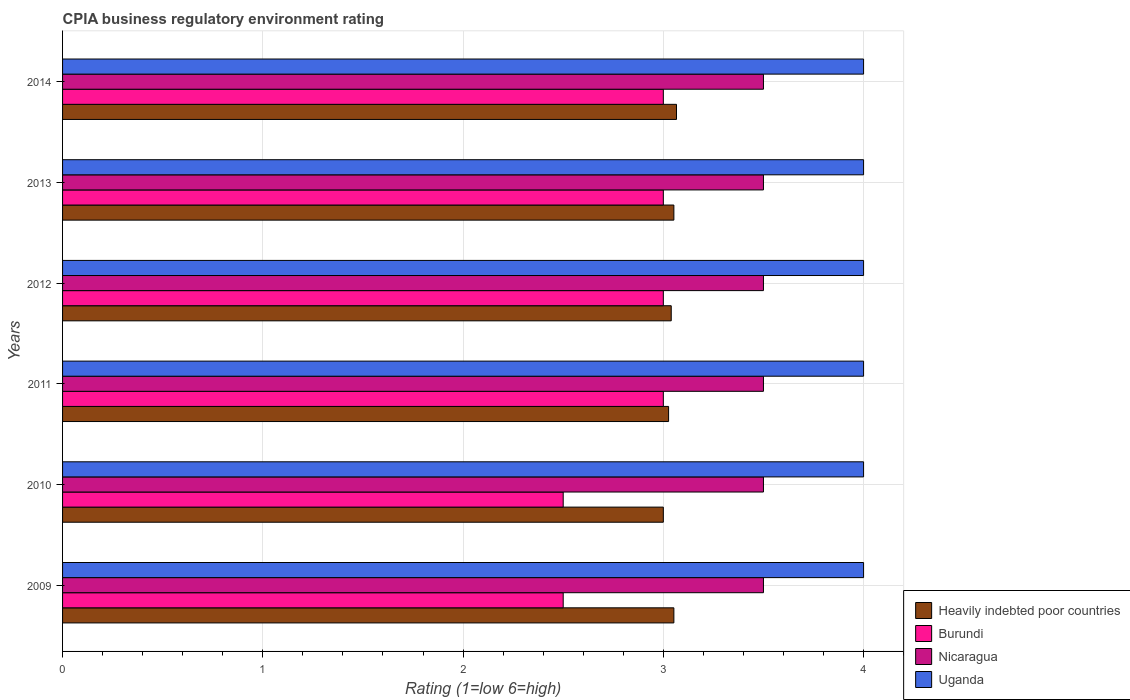How many groups of bars are there?
Offer a terse response. 6. Are the number of bars on each tick of the Y-axis equal?
Your answer should be compact. Yes. How many bars are there on the 4th tick from the top?
Your response must be concise. 4. How many bars are there on the 1st tick from the bottom?
Your answer should be very brief. 4. What is the label of the 2nd group of bars from the top?
Your response must be concise. 2013. In how many cases, is the number of bars for a given year not equal to the number of legend labels?
Keep it short and to the point. 0. Across all years, what is the minimum CPIA rating in Uganda?
Your response must be concise. 4. In which year was the CPIA rating in Heavily indebted poor countries maximum?
Your answer should be compact. 2014. In which year was the CPIA rating in Heavily indebted poor countries minimum?
Ensure brevity in your answer.  2010. What is the total CPIA rating in Heavily indebted poor countries in the graph?
Offer a very short reply. 18.24. What is the difference between the CPIA rating in Heavily indebted poor countries in 2011 and the CPIA rating in Burundi in 2014?
Make the answer very short. 0.03. Is the CPIA rating in Uganda in 2011 less than that in 2014?
Your response must be concise. No. What is the difference between the highest and the lowest CPIA rating in Nicaragua?
Ensure brevity in your answer.  0. In how many years, is the CPIA rating in Burundi greater than the average CPIA rating in Burundi taken over all years?
Offer a very short reply. 4. Is the sum of the CPIA rating in Burundi in 2012 and 2013 greater than the maximum CPIA rating in Nicaragua across all years?
Give a very brief answer. Yes. Is it the case that in every year, the sum of the CPIA rating in Heavily indebted poor countries and CPIA rating in Uganda is greater than the sum of CPIA rating in Nicaragua and CPIA rating in Burundi?
Make the answer very short. No. What does the 2nd bar from the top in 2010 represents?
Your answer should be compact. Nicaragua. What does the 2nd bar from the bottom in 2010 represents?
Offer a terse response. Burundi. Is it the case that in every year, the sum of the CPIA rating in Heavily indebted poor countries and CPIA rating in Nicaragua is greater than the CPIA rating in Uganda?
Keep it short and to the point. Yes. Does the graph contain any zero values?
Ensure brevity in your answer.  No. How many legend labels are there?
Offer a very short reply. 4. How are the legend labels stacked?
Your answer should be very brief. Vertical. What is the title of the graph?
Give a very brief answer. CPIA business regulatory environment rating. Does "Comoros" appear as one of the legend labels in the graph?
Your response must be concise. No. What is the label or title of the X-axis?
Offer a terse response. Rating (1=low 6=high). What is the label or title of the Y-axis?
Provide a succinct answer. Years. What is the Rating (1=low 6=high) of Heavily indebted poor countries in 2009?
Keep it short and to the point. 3.05. What is the Rating (1=low 6=high) of Heavily indebted poor countries in 2010?
Make the answer very short. 3. What is the Rating (1=low 6=high) of Heavily indebted poor countries in 2011?
Your answer should be compact. 3.03. What is the Rating (1=low 6=high) in Uganda in 2011?
Offer a very short reply. 4. What is the Rating (1=low 6=high) in Heavily indebted poor countries in 2012?
Your answer should be very brief. 3.04. What is the Rating (1=low 6=high) in Burundi in 2012?
Provide a succinct answer. 3. What is the Rating (1=low 6=high) of Nicaragua in 2012?
Give a very brief answer. 3.5. What is the Rating (1=low 6=high) in Uganda in 2012?
Give a very brief answer. 4. What is the Rating (1=low 6=high) in Heavily indebted poor countries in 2013?
Provide a succinct answer. 3.05. What is the Rating (1=low 6=high) in Burundi in 2013?
Make the answer very short. 3. What is the Rating (1=low 6=high) of Heavily indebted poor countries in 2014?
Your answer should be very brief. 3.07. What is the Rating (1=low 6=high) of Burundi in 2014?
Keep it short and to the point. 3. What is the Rating (1=low 6=high) in Nicaragua in 2014?
Provide a short and direct response. 3.5. Across all years, what is the maximum Rating (1=low 6=high) in Heavily indebted poor countries?
Give a very brief answer. 3.07. Across all years, what is the maximum Rating (1=low 6=high) of Burundi?
Offer a very short reply. 3. Across all years, what is the maximum Rating (1=low 6=high) in Nicaragua?
Offer a terse response. 3.5. Across all years, what is the minimum Rating (1=low 6=high) of Uganda?
Provide a succinct answer. 4. What is the total Rating (1=low 6=high) of Heavily indebted poor countries in the graph?
Your answer should be very brief. 18.24. What is the total Rating (1=low 6=high) in Burundi in the graph?
Your response must be concise. 17. What is the total Rating (1=low 6=high) in Nicaragua in the graph?
Ensure brevity in your answer.  21. What is the difference between the Rating (1=low 6=high) of Heavily indebted poor countries in 2009 and that in 2010?
Give a very brief answer. 0.05. What is the difference between the Rating (1=low 6=high) of Heavily indebted poor countries in 2009 and that in 2011?
Your answer should be very brief. 0.03. What is the difference between the Rating (1=low 6=high) in Uganda in 2009 and that in 2011?
Offer a terse response. 0. What is the difference between the Rating (1=low 6=high) in Heavily indebted poor countries in 2009 and that in 2012?
Your response must be concise. 0.01. What is the difference between the Rating (1=low 6=high) of Burundi in 2009 and that in 2012?
Your answer should be compact. -0.5. What is the difference between the Rating (1=low 6=high) in Nicaragua in 2009 and that in 2012?
Provide a succinct answer. 0. What is the difference between the Rating (1=low 6=high) in Uganda in 2009 and that in 2012?
Ensure brevity in your answer.  0. What is the difference between the Rating (1=low 6=high) in Heavily indebted poor countries in 2009 and that in 2013?
Keep it short and to the point. 0. What is the difference between the Rating (1=low 6=high) of Nicaragua in 2009 and that in 2013?
Give a very brief answer. 0. What is the difference between the Rating (1=low 6=high) in Uganda in 2009 and that in 2013?
Provide a succinct answer. 0. What is the difference between the Rating (1=low 6=high) in Heavily indebted poor countries in 2009 and that in 2014?
Provide a succinct answer. -0.01. What is the difference between the Rating (1=low 6=high) in Nicaragua in 2009 and that in 2014?
Provide a succinct answer. 0. What is the difference between the Rating (1=low 6=high) in Heavily indebted poor countries in 2010 and that in 2011?
Provide a succinct answer. -0.03. What is the difference between the Rating (1=low 6=high) of Burundi in 2010 and that in 2011?
Give a very brief answer. -0.5. What is the difference between the Rating (1=low 6=high) of Nicaragua in 2010 and that in 2011?
Provide a succinct answer. 0. What is the difference between the Rating (1=low 6=high) of Uganda in 2010 and that in 2011?
Provide a succinct answer. 0. What is the difference between the Rating (1=low 6=high) in Heavily indebted poor countries in 2010 and that in 2012?
Give a very brief answer. -0.04. What is the difference between the Rating (1=low 6=high) of Uganda in 2010 and that in 2012?
Keep it short and to the point. 0. What is the difference between the Rating (1=low 6=high) in Heavily indebted poor countries in 2010 and that in 2013?
Provide a short and direct response. -0.05. What is the difference between the Rating (1=low 6=high) in Burundi in 2010 and that in 2013?
Your answer should be compact. -0.5. What is the difference between the Rating (1=low 6=high) of Heavily indebted poor countries in 2010 and that in 2014?
Give a very brief answer. -0.07. What is the difference between the Rating (1=low 6=high) of Heavily indebted poor countries in 2011 and that in 2012?
Give a very brief answer. -0.01. What is the difference between the Rating (1=low 6=high) of Burundi in 2011 and that in 2012?
Offer a terse response. 0. What is the difference between the Rating (1=low 6=high) of Nicaragua in 2011 and that in 2012?
Offer a very short reply. 0. What is the difference between the Rating (1=low 6=high) in Uganda in 2011 and that in 2012?
Your response must be concise. 0. What is the difference between the Rating (1=low 6=high) of Heavily indebted poor countries in 2011 and that in 2013?
Keep it short and to the point. -0.03. What is the difference between the Rating (1=low 6=high) of Burundi in 2011 and that in 2013?
Your response must be concise. 0. What is the difference between the Rating (1=low 6=high) of Heavily indebted poor countries in 2011 and that in 2014?
Provide a succinct answer. -0.04. What is the difference between the Rating (1=low 6=high) in Burundi in 2011 and that in 2014?
Offer a very short reply. 0. What is the difference between the Rating (1=low 6=high) of Heavily indebted poor countries in 2012 and that in 2013?
Your response must be concise. -0.01. What is the difference between the Rating (1=low 6=high) in Uganda in 2012 and that in 2013?
Give a very brief answer. 0. What is the difference between the Rating (1=low 6=high) of Heavily indebted poor countries in 2012 and that in 2014?
Provide a short and direct response. -0.03. What is the difference between the Rating (1=low 6=high) in Burundi in 2012 and that in 2014?
Provide a short and direct response. 0. What is the difference between the Rating (1=low 6=high) in Heavily indebted poor countries in 2013 and that in 2014?
Offer a terse response. -0.01. What is the difference between the Rating (1=low 6=high) of Burundi in 2013 and that in 2014?
Your answer should be very brief. 0. What is the difference between the Rating (1=low 6=high) of Heavily indebted poor countries in 2009 and the Rating (1=low 6=high) of Burundi in 2010?
Your response must be concise. 0.55. What is the difference between the Rating (1=low 6=high) of Heavily indebted poor countries in 2009 and the Rating (1=low 6=high) of Nicaragua in 2010?
Your answer should be very brief. -0.45. What is the difference between the Rating (1=low 6=high) in Heavily indebted poor countries in 2009 and the Rating (1=low 6=high) in Uganda in 2010?
Keep it short and to the point. -0.95. What is the difference between the Rating (1=low 6=high) of Heavily indebted poor countries in 2009 and the Rating (1=low 6=high) of Burundi in 2011?
Your answer should be very brief. 0.05. What is the difference between the Rating (1=low 6=high) in Heavily indebted poor countries in 2009 and the Rating (1=low 6=high) in Nicaragua in 2011?
Make the answer very short. -0.45. What is the difference between the Rating (1=low 6=high) of Heavily indebted poor countries in 2009 and the Rating (1=low 6=high) of Uganda in 2011?
Offer a very short reply. -0.95. What is the difference between the Rating (1=low 6=high) of Burundi in 2009 and the Rating (1=low 6=high) of Nicaragua in 2011?
Your answer should be very brief. -1. What is the difference between the Rating (1=low 6=high) of Burundi in 2009 and the Rating (1=low 6=high) of Uganda in 2011?
Provide a succinct answer. -1.5. What is the difference between the Rating (1=low 6=high) of Heavily indebted poor countries in 2009 and the Rating (1=low 6=high) of Burundi in 2012?
Offer a terse response. 0.05. What is the difference between the Rating (1=low 6=high) of Heavily indebted poor countries in 2009 and the Rating (1=low 6=high) of Nicaragua in 2012?
Offer a very short reply. -0.45. What is the difference between the Rating (1=low 6=high) of Heavily indebted poor countries in 2009 and the Rating (1=low 6=high) of Uganda in 2012?
Your answer should be very brief. -0.95. What is the difference between the Rating (1=low 6=high) in Nicaragua in 2009 and the Rating (1=low 6=high) in Uganda in 2012?
Offer a very short reply. -0.5. What is the difference between the Rating (1=low 6=high) in Heavily indebted poor countries in 2009 and the Rating (1=low 6=high) in Burundi in 2013?
Offer a terse response. 0.05. What is the difference between the Rating (1=low 6=high) in Heavily indebted poor countries in 2009 and the Rating (1=low 6=high) in Nicaragua in 2013?
Make the answer very short. -0.45. What is the difference between the Rating (1=low 6=high) in Heavily indebted poor countries in 2009 and the Rating (1=low 6=high) in Uganda in 2013?
Your response must be concise. -0.95. What is the difference between the Rating (1=low 6=high) in Burundi in 2009 and the Rating (1=low 6=high) in Uganda in 2013?
Keep it short and to the point. -1.5. What is the difference between the Rating (1=low 6=high) in Nicaragua in 2009 and the Rating (1=low 6=high) in Uganda in 2013?
Provide a short and direct response. -0.5. What is the difference between the Rating (1=low 6=high) in Heavily indebted poor countries in 2009 and the Rating (1=low 6=high) in Burundi in 2014?
Keep it short and to the point. 0.05. What is the difference between the Rating (1=low 6=high) in Heavily indebted poor countries in 2009 and the Rating (1=low 6=high) in Nicaragua in 2014?
Provide a short and direct response. -0.45. What is the difference between the Rating (1=low 6=high) in Heavily indebted poor countries in 2009 and the Rating (1=low 6=high) in Uganda in 2014?
Make the answer very short. -0.95. What is the difference between the Rating (1=low 6=high) of Burundi in 2009 and the Rating (1=low 6=high) of Uganda in 2014?
Offer a very short reply. -1.5. What is the difference between the Rating (1=low 6=high) of Heavily indebted poor countries in 2010 and the Rating (1=low 6=high) of Uganda in 2011?
Offer a terse response. -1. What is the difference between the Rating (1=low 6=high) of Burundi in 2010 and the Rating (1=low 6=high) of Nicaragua in 2011?
Keep it short and to the point. -1. What is the difference between the Rating (1=low 6=high) of Burundi in 2010 and the Rating (1=low 6=high) of Uganda in 2011?
Keep it short and to the point. -1.5. What is the difference between the Rating (1=low 6=high) of Nicaragua in 2010 and the Rating (1=low 6=high) of Uganda in 2011?
Make the answer very short. -0.5. What is the difference between the Rating (1=low 6=high) in Heavily indebted poor countries in 2010 and the Rating (1=low 6=high) in Burundi in 2012?
Your response must be concise. 0. What is the difference between the Rating (1=low 6=high) in Heavily indebted poor countries in 2010 and the Rating (1=low 6=high) in Nicaragua in 2012?
Ensure brevity in your answer.  -0.5. What is the difference between the Rating (1=low 6=high) of Heavily indebted poor countries in 2010 and the Rating (1=low 6=high) of Uganda in 2012?
Offer a terse response. -1. What is the difference between the Rating (1=low 6=high) in Burundi in 2010 and the Rating (1=low 6=high) in Nicaragua in 2012?
Provide a succinct answer. -1. What is the difference between the Rating (1=low 6=high) of Heavily indebted poor countries in 2010 and the Rating (1=low 6=high) of Burundi in 2013?
Ensure brevity in your answer.  0. What is the difference between the Rating (1=low 6=high) of Heavily indebted poor countries in 2010 and the Rating (1=low 6=high) of Nicaragua in 2013?
Your response must be concise. -0.5. What is the difference between the Rating (1=low 6=high) of Heavily indebted poor countries in 2010 and the Rating (1=low 6=high) of Uganda in 2013?
Give a very brief answer. -1. What is the difference between the Rating (1=low 6=high) in Burundi in 2010 and the Rating (1=low 6=high) in Nicaragua in 2013?
Your answer should be very brief. -1. What is the difference between the Rating (1=low 6=high) in Burundi in 2010 and the Rating (1=low 6=high) in Uganda in 2013?
Your response must be concise. -1.5. What is the difference between the Rating (1=low 6=high) of Nicaragua in 2010 and the Rating (1=low 6=high) of Uganda in 2013?
Offer a very short reply. -0.5. What is the difference between the Rating (1=low 6=high) of Nicaragua in 2010 and the Rating (1=low 6=high) of Uganda in 2014?
Offer a very short reply. -0.5. What is the difference between the Rating (1=low 6=high) in Heavily indebted poor countries in 2011 and the Rating (1=low 6=high) in Burundi in 2012?
Provide a succinct answer. 0.03. What is the difference between the Rating (1=low 6=high) of Heavily indebted poor countries in 2011 and the Rating (1=low 6=high) of Nicaragua in 2012?
Give a very brief answer. -0.47. What is the difference between the Rating (1=low 6=high) of Heavily indebted poor countries in 2011 and the Rating (1=low 6=high) of Uganda in 2012?
Offer a very short reply. -0.97. What is the difference between the Rating (1=low 6=high) in Heavily indebted poor countries in 2011 and the Rating (1=low 6=high) in Burundi in 2013?
Give a very brief answer. 0.03. What is the difference between the Rating (1=low 6=high) in Heavily indebted poor countries in 2011 and the Rating (1=low 6=high) in Nicaragua in 2013?
Offer a terse response. -0.47. What is the difference between the Rating (1=low 6=high) of Heavily indebted poor countries in 2011 and the Rating (1=low 6=high) of Uganda in 2013?
Your answer should be compact. -0.97. What is the difference between the Rating (1=low 6=high) in Burundi in 2011 and the Rating (1=low 6=high) in Nicaragua in 2013?
Keep it short and to the point. -0.5. What is the difference between the Rating (1=low 6=high) of Burundi in 2011 and the Rating (1=low 6=high) of Uganda in 2013?
Give a very brief answer. -1. What is the difference between the Rating (1=low 6=high) of Heavily indebted poor countries in 2011 and the Rating (1=low 6=high) of Burundi in 2014?
Your answer should be very brief. 0.03. What is the difference between the Rating (1=low 6=high) in Heavily indebted poor countries in 2011 and the Rating (1=low 6=high) in Nicaragua in 2014?
Provide a short and direct response. -0.47. What is the difference between the Rating (1=low 6=high) of Heavily indebted poor countries in 2011 and the Rating (1=low 6=high) of Uganda in 2014?
Keep it short and to the point. -0.97. What is the difference between the Rating (1=low 6=high) of Burundi in 2011 and the Rating (1=low 6=high) of Uganda in 2014?
Offer a terse response. -1. What is the difference between the Rating (1=low 6=high) of Heavily indebted poor countries in 2012 and the Rating (1=low 6=high) of Burundi in 2013?
Keep it short and to the point. 0.04. What is the difference between the Rating (1=low 6=high) of Heavily indebted poor countries in 2012 and the Rating (1=low 6=high) of Nicaragua in 2013?
Ensure brevity in your answer.  -0.46. What is the difference between the Rating (1=low 6=high) of Heavily indebted poor countries in 2012 and the Rating (1=low 6=high) of Uganda in 2013?
Your response must be concise. -0.96. What is the difference between the Rating (1=low 6=high) in Burundi in 2012 and the Rating (1=low 6=high) in Nicaragua in 2013?
Your answer should be compact. -0.5. What is the difference between the Rating (1=low 6=high) in Burundi in 2012 and the Rating (1=low 6=high) in Uganda in 2013?
Offer a very short reply. -1. What is the difference between the Rating (1=low 6=high) in Heavily indebted poor countries in 2012 and the Rating (1=low 6=high) in Burundi in 2014?
Keep it short and to the point. 0.04. What is the difference between the Rating (1=low 6=high) of Heavily indebted poor countries in 2012 and the Rating (1=low 6=high) of Nicaragua in 2014?
Your answer should be very brief. -0.46. What is the difference between the Rating (1=low 6=high) of Heavily indebted poor countries in 2012 and the Rating (1=low 6=high) of Uganda in 2014?
Make the answer very short. -0.96. What is the difference between the Rating (1=low 6=high) in Nicaragua in 2012 and the Rating (1=low 6=high) in Uganda in 2014?
Make the answer very short. -0.5. What is the difference between the Rating (1=low 6=high) in Heavily indebted poor countries in 2013 and the Rating (1=low 6=high) in Burundi in 2014?
Your response must be concise. 0.05. What is the difference between the Rating (1=low 6=high) in Heavily indebted poor countries in 2013 and the Rating (1=low 6=high) in Nicaragua in 2014?
Provide a short and direct response. -0.45. What is the difference between the Rating (1=low 6=high) of Heavily indebted poor countries in 2013 and the Rating (1=low 6=high) of Uganda in 2014?
Your response must be concise. -0.95. What is the difference between the Rating (1=low 6=high) of Burundi in 2013 and the Rating (1=low 6=high) of Uganda in 2014?
Ensure brevity in your answer.  -1. What is the difference between the Rating (1=low 6=high) of Nicaragua in 2013 and the Rating (1=low 6=high) of Uganda in 2014?
Offer a very short reply. -0.5. What is the average Rating (1=low 6=high) of Heavily indebted poor countries per year?
Your answer should be compact. 3.04. What is the average Rating (1=low 6=high) in Burundi per year?
Make the answer very short. 2.83. What is the average Rating (1=low 6=high) of Nicaragua per year?
Give a very brief answer. 3.5. In the year 2009, what is the difference between the Rating (1=low 6=high) in Heavily indebted poor countries and Rating (1=low 6=high) in Burundi?
Offer a very short reply. 0.55. In the year 2009, what is the difference between the Rating (1=low 6=high) in Heavily indebted poor countries and Rating (1=low 6=high) in Nicaragua?
Provide a succinct answer. -0.45. In the year 2009, what is the difference between the Rating (1=low 6=high) in Heavily indebted poor countries and Rating (1=low 6=high) in Uganda?
Provide a succinct answer. -0.95. In the year 2009, what is the difference between the Rating (1=low 6=high) of Nicaragua and Rating (1=low 6=high) of Uganda?
Your answer should be compact. -0.5. In the year 2010, what is the difference between the Rating (1=low 6=high) in Heavily indebted poor countries and Rating (1=low 6=high) in Burundi?
Your answer should be very brief. 0.5. In the year 2010, what is the difference between the Rating (1=low 6=high) of Heavily indebted poor countries and Rating (1=low 6=high) of Uganda?
Offer a very short reply. -1. In the year 2010, what is the difference between the Rating (1=low 6=high) in Burundi and Rating (1=low 6=high) in Nicaragua?
Offer a terse response. -1. In the year 2011, what is the difference between the Rating (1=low 6=high) in Heavily indebted poor countries and Rating (1=low 6=high) in Burundi?
Make the answer very short. 0.03. In the year 2011, what is the difference between the Rating (1=low 6=high) in Heavily indebted poor countries and Rating (1=low 6=high) in Nicaragua?
Your answer should be very brief. -0.47. In the year 2011, what is the difference between the Rating (1=low 6=high) in Heavily indebted poor countries and Rating (1=low 6=high) in Uganda?
Ensure brevity in your answer.  -0.97. In the year 2011, what is the difference between the Rating (1=low 6=high) of Burundi and Rating (1=low 6=high) of Nicaragua?
Give a very brief answer. -0.5. In the year 2011, what is the difference between the Rating (1=low 6=high) of Nicaragua and Rating (1=low 6=high) of Uganda?
Your answer should be compact. -0.5. In the year 2012, what is the difference between the Rating (1=low 6=high) in Heavily indebted poor countries and Rating (1=low 6=high) in Burundi?
Offer a terse response. 0.04. In the year 2012, what is the difference between the Rating (1=low 6=high) in Heavily indebted poor countries and Rating (1=low 6=high) in Nicaragua?
Make the answer very short. -0.46. In the year 2012, what is the difference between the Rating (1=low 6=high) of Heavily indebted poor countries and Rating (1=low 6=high) of Uganda?
Provide a succinct answer. -0.96. In the year 2012, what is the difference between the Rating (1=low 6=high) in Nicaragua and Rating (1=low 6=high) in Uganda?
Ensure brevity in your answer.  -0.5. In the year 2013, what is the difference between the Rating (1=low 6=high) in Heavily indebted poor countries and Rating (1=low 6=high) in Burundi?
Offer a terse response. 0.05. In the year 2013, what is the difference between the Rating (1=low 6=high) in Heavily indebted poor countries and Rating (1=low 6=high) in Nicaragua?
Provide a short and direct response. -0.45. In the year 2013, what is the difference between the Rating (1=low 6=high) of Heavily indebted poor countries and Rating (1=low 6=high) of Uganda?
Provide a short and direct response. -0.95. In the year 2013, what is the difference between the Rating (1=low 6=high) of Nicaragua and Rating (1=low 6=high) of Uganda?
Your answer should be compact. -0.5. In the year 2014, what is the difference between the Rating (1=low 6=high) of Heavily indebted poor countries and Rating (1=low 6=high) of Burundi?
Your response must be concise. 0.07. In the year 2014, what is the difference between the Rating (1=low 6=high) of Heavily indebted poor countries and Rating (1=low 6=high) of Nicaragua?
Your answer should be very brief. -0.43. In the year 2014, what is the difference between the Rating (1=low 6=high) of Heavily indebted poor countries and Rating (1=low 6=high) of Uganda?
Give a very brief answer. -0.93. In the year 2014, what is the difference between the Rating (1=low 6=high) of Nicaragua and Rating (1=low 6=high) of Uganda?
Offer a very short reply. -0.5. What is the ratio of the Rating (1=low 6=high) of Heavily indebted poor countries in 2009 to that in 2010?
Your response must be concise. 1.02. What is the ratio of the Rating (1=low 6=high) in Heavily indebted poor countries in 2009 to that in 2011?
Give a very brief answer. 1.01. What is the ratio of the Rating (1=low 6=high) in Burundi in 2009 to that in 2011?
Your response must be concise. 0.83. What is the ratio of the Rating (1=low 6=high) in Uganda in 2009 to that in 2011?
Provide a succinct answer. 1. What is the ratio of the Rating (1=low 6=high) of Nicaragua in 2009 to that in 2012?
Keep it short and to the point. 1. What is the ratio of the Rating (1=low 6=high) of Uganda in 2009 to that in 2012?
Offer a terse response. 1. What is the ratio of the Rating (1=low 6=high) in Heavily indebted poor countries in 2009 to that in 2013?
Your response must be concise. 1. What is the ratio of the Rating (1=low 6=high) of Burundi in 2009 to that in 2013?
Keep it short and to the point. 0.83. What is the ratio of the Rating (1=low 6=high) in Nicaragua in 2009 to that in 2013?
Ensure brevity in your answer.  1. What is the ratio of the Rating (1=low 6=high) in Uganda in 2009 to that in 2013?
Your answer should be compact. 1. What is the ratio of the Rating (1=low 6=high) in Uganda in 2009 to that in 2014?
Provide a succinct answer. 1. What is the ratio of the Rating (1=low 6=high) of Burundi in 2010 to that in 2011?
Your answer should be very brief. 0.83. What is the ratio of the Rating (1=low 6=high) of Nicaragua in 2010 to that in 2011?
Keep it short and to the point. 1. What is the ratio of the Rating (1=low 6=high) of Uganda in 2010 to that in 2011?
Your response must be concise. 1. What is the ratio of the Rating (1=low 6=high) in Heavily indebted poor countries in 2010 to that in 2012?
Give a very brief answer. 0.99. What is the ratio of the Rating (1=low 6=high) of Nicaragua in 2010 to that in 2012?
Provide a succinct answer. 1. What is the ratio of the Rating (1=low 6=high) of Uganda in 2010 to that in 2012?
Give a very brief answer. 1. What is the ratio of the Rating (1=low 6=high) in Heavily indebted poor countries in 2010 to that in 2013?
Your answer should be compact. 0.98. What is the ratio of the Rating (1=low 6=high) in Burundi in 2010 to that in 2013?
Offer a terse response. 0.83. What is the ratio of the Rating (1=low 6=high) in Heavily indebted poor countries in 2010 to that in 2014?
Give a very brief answer. 0.98. What is the ratio of the Rating (1=low 6=high) in Burundi in 2010 to that in 2014?
Keep it short and to the point. 0.83. What is the ratio of the Rating (1=low 6=high) in Nicaragua in 2010 to that in 2014?
Your answer should be very brief. 1. What is the ratio of the Rating (1=low 6=high) in Heavily indebted poor countries in 2011 to that in 2012?
Offer a terse response. 1. What is the ratio of the Rating (1=low 6=high) of Burundi in 2011 to that in 2012?
Offer a very short reply. 1. What is the ratio of the Rating (1=low 6=high) in Nicaragua in 2011 to that in 2012?
Your response must be concise. 1. What is the ratio of the Rating (1=low 6=high) of Uganda in 2011 to that in 2012?
Make the answer very short. 1. What is the ratio of the Rating (1=low 6=high) of Nicaragua in 2011 to that in 2013?
Offer a terse response. 1. What is the ratio of the Rating (1=low 6=high) of Uganda in 2011 to that in 2013?
Keep it short and to the point. 1. What is the ratio of the Rating (1=low 6=high) of Heavily indebted poor countries in 2011 to that in 2014?
Give a very brief answer. 0.99. What is the ratio of the Rating (1=low 6=high) of Uganda in 2011 to that in 2014?
Give a very brief answer. 1. What is the ratio of the Rating (1=low 6=high) of Heavily indebted poor countries in 2012 to that in 2013?
Keep it short and to the point. 1. What is the ratio of the Rating (1=low 6=high) of Nicaragua in 2012 to that in 2013?
Offer a very short reply. 1. What is the ratio of the Rating (1=low 6=high) of Uganda in 2012 to that in 2013?
Give a very brief answer. 1. What is the ratio of the Rating (1=low 6=high) of Heavily indebted poor countries in 2012 to that in 2014?
Make the answer very short. 0.99. What is the ratio of the Rating (1=low 6=high) in Nicaragua in 2012 to that in 2014?
Keep it short and to the point. 1. What is the ratio of the Rating (1=low 6=high) in Burundi in 2013 to that in 2014?
Your answer should be very brief. 1. What is the ratio of the Rating (1=low 6=high) in Uganda in 2013 to that in 2014?
Your response must be concise. 1. What is the difference between the highest and the second highest Rating (1=low 6=high) in Heavily indebted poor countries?
Provide a succinct answer. 0.01. What is the difference between the highest and the second highest Rating (1=low 6=high) in Burundi?
Ensure brevity in your answer.  0. What is the difference between the highest and the lowest Rating (1=low 6=high) of Heavily indebted poor countries?
Ensure brevity in your answer.  0.07. What is the difference between the highest and the lowest Rating (1=low 6=high) in Burundi?
Provide a succinct answer. 0.5. What is the difference between the highest and the lowest Rating (1=low 6=high) of Nicaragua?
Your answer should be very brief. 0. What is the difference between the highest and the lowest Rating (1=low 6=high) in Uganda?
Make the answer very short. 0. 